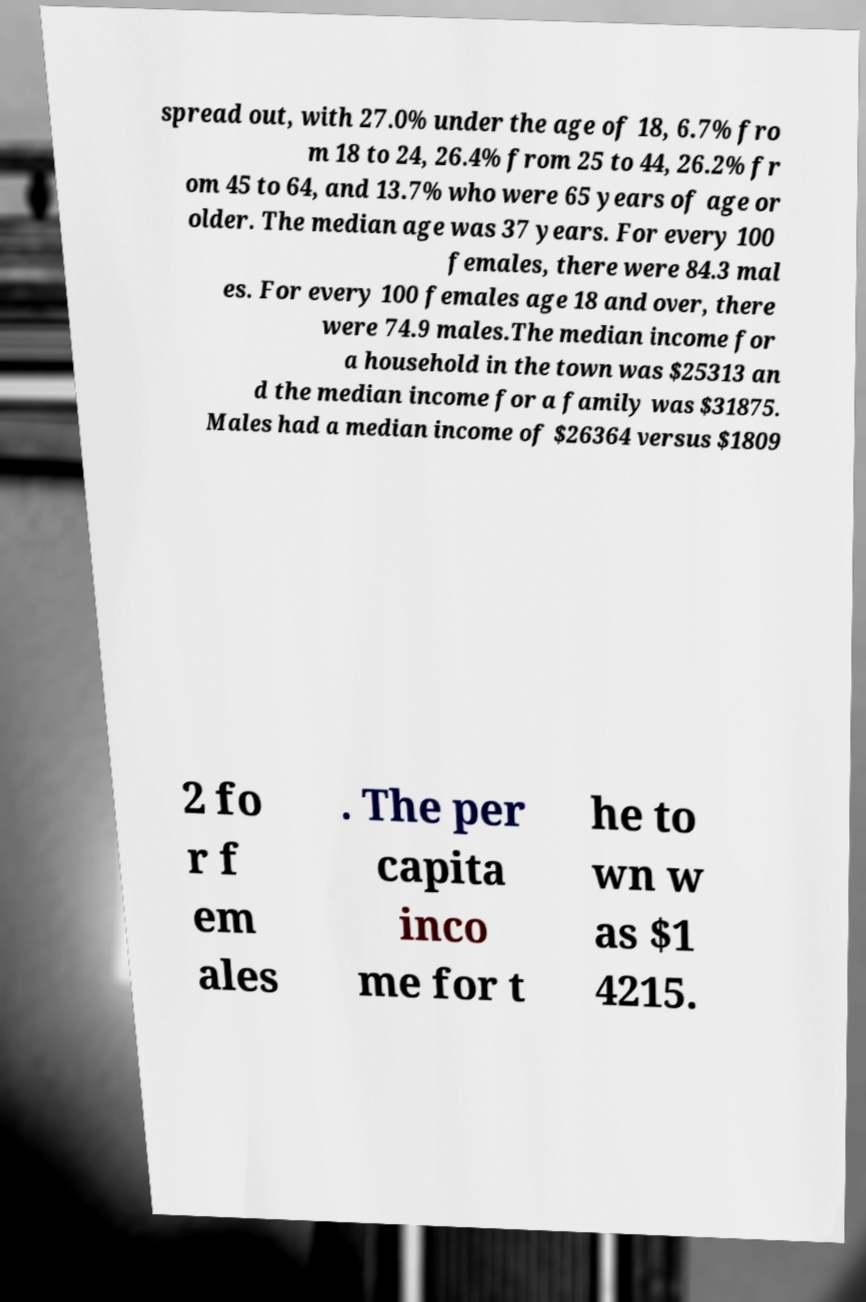Please read and relay the text visible in this image. What does it say? spread out, with 27.0% under the age of 18, 6.7% fro m 18 to 24, 26.4% from 25 to 44, 26.2% fr om 45 to 64, and 13.7% who were 65 years of age or older. The median age was 37 years. For every 100 females, there were 84.3 mal es. For every 100 females age 18 and over, there were 74.9 males.The median income for a household in the town was $25313 an d the median income for a family was $31875. Males had a median income of $26364 versus $1809 2 fo r f em ales . The per capita inco me for t he to wn w as $1 4215. 